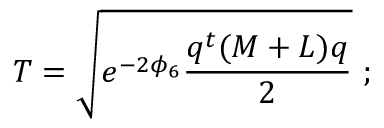Convert formula to latex. <formula><loc_0><loc_0><loc_500><loc_500>T = \sqrt { e ^ { - 2 \phi _ { 6 } } \frac { q ^ { t } ( M + L ) q } { 2 } } \ ;</formula> 